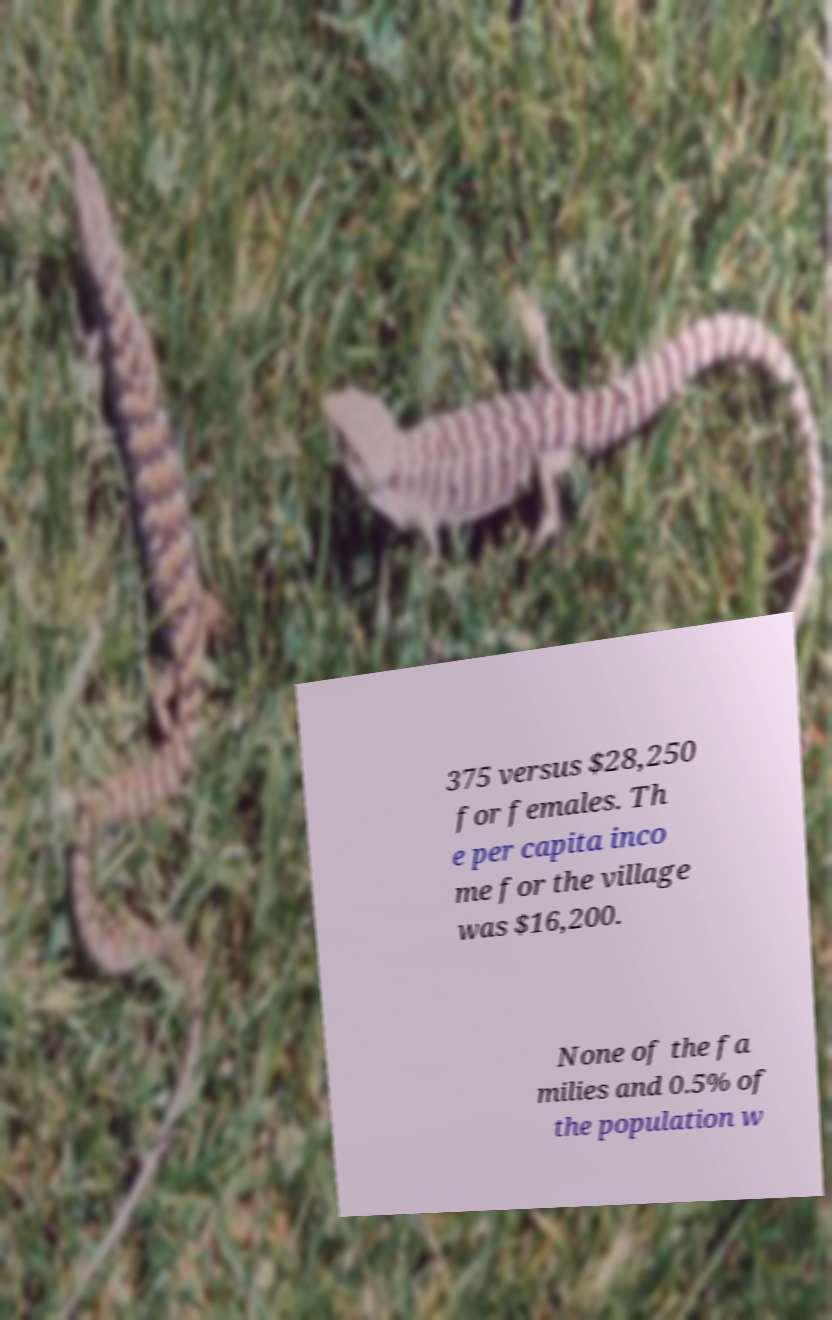For documentation purposes, I need the text within this image transcribed. Could you provide that? 375 versus $28,250 for females. Th e per capita inco me for the village was $16,200. None of the fa milies and 0.5% of the population w 